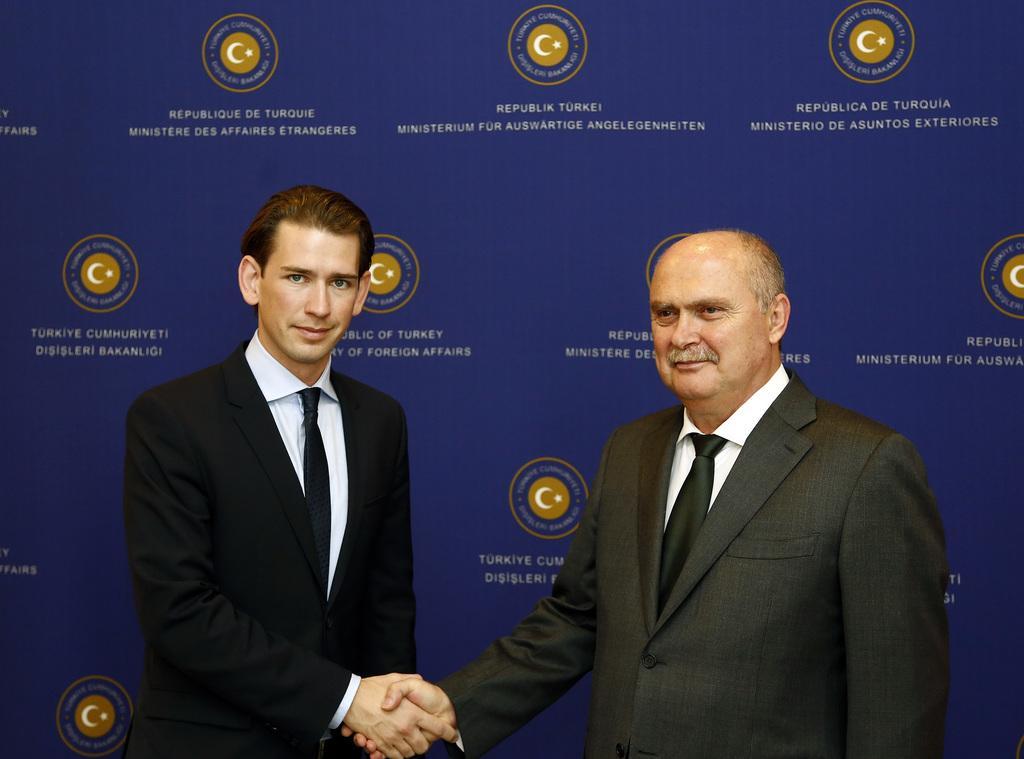Could you give a brief overview of what you see in this image? In this image we can see two persons standing. One person is wearing black coat and black tie. Other person is wearing a grey coat. 